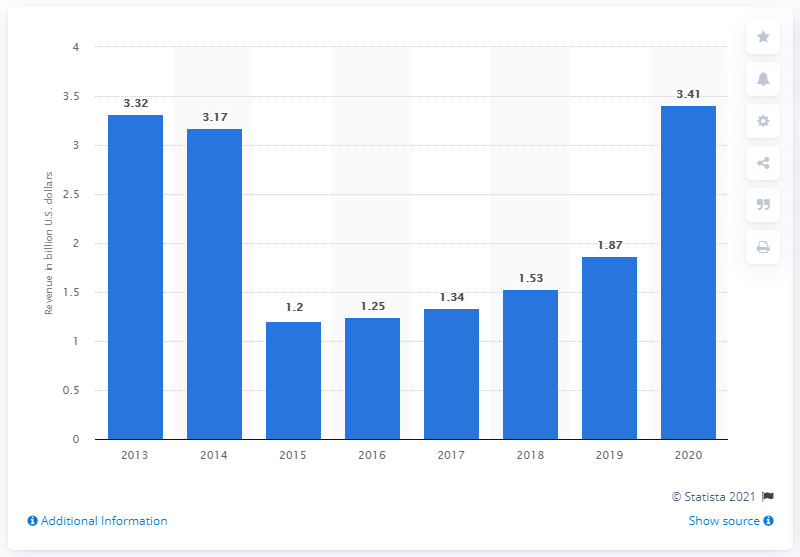Identify some key points in this picture. In 2020, Gannett generated approximately 3.41 billion US dollars in operating revenue. 